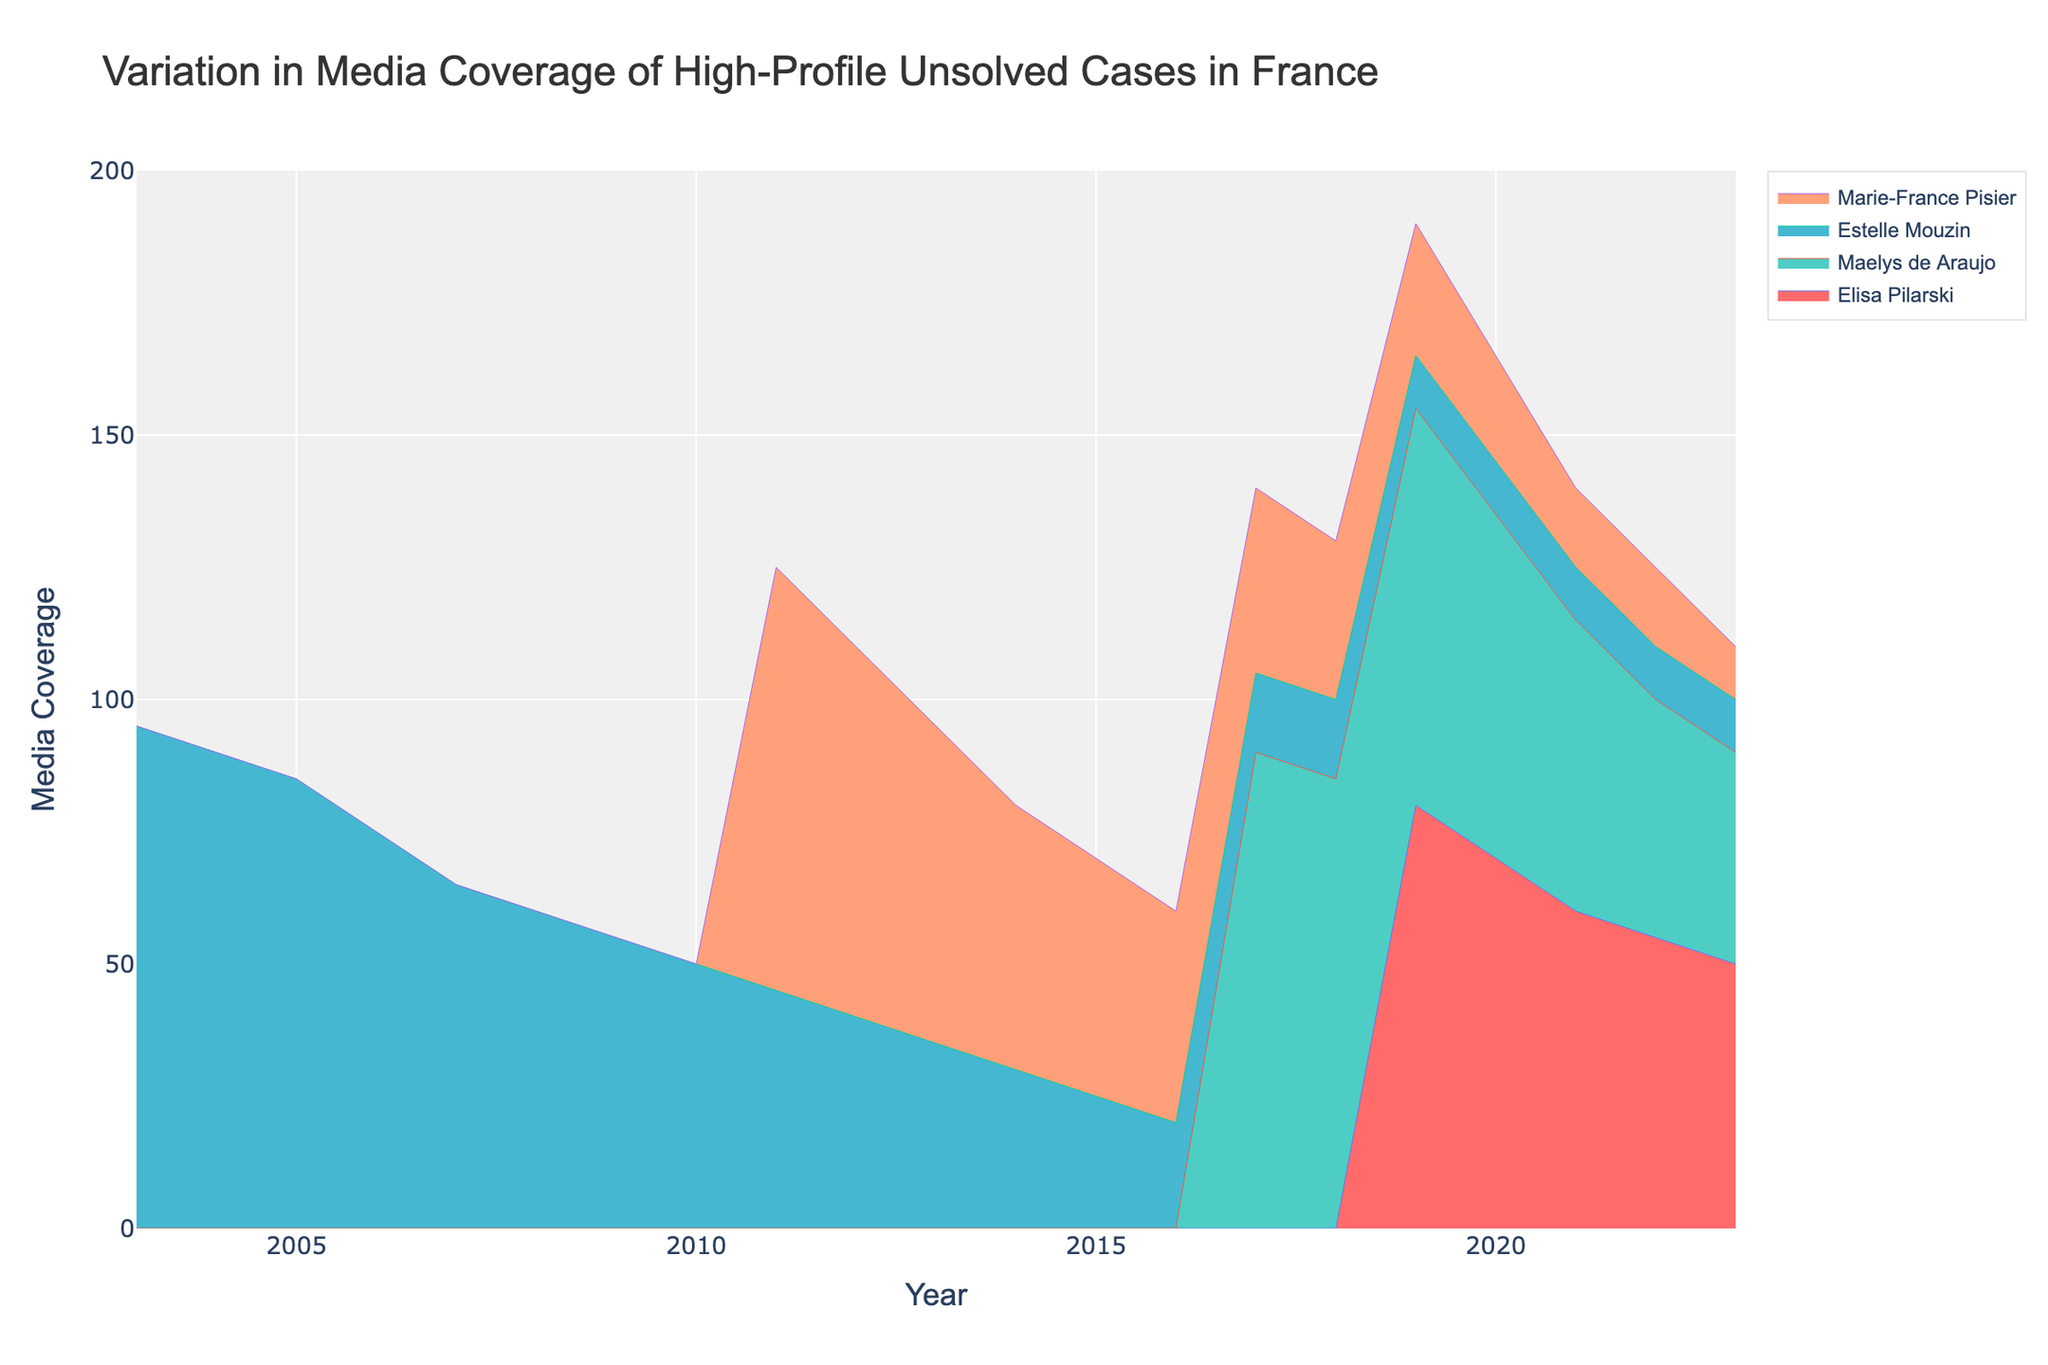What is the title of the figure? The title is usually written at the top of a plot, helping to give context to the data represented. Here it reads 'Variation in Media Coverage of High-Profile Unsolved Cases in France'.
Answer: Variation in Media Coverage of High-Profile Unsolved Cases in France What are the axes labels in the figure? Axes labels provide information about what each axis represents. Here, the x-axis is labeled 'Year' and the y-axis is labeled 'Media Coverage'.
Answer: 'Year' and 'Media Coverage' Which case had the highest media coverage in the initial year provided for that case? By looking at each initial year for all cases, we see that Estelle Mouzin in 2003 has the highest initial media coverage with a value of 95.
Answer: Estelle Mouzin in 2003 Between 2017 and 2018, did public awareness for Marie-France Pisier increase, decrease, or stay the same? We look at the 'Public Awareness' values for Marie-France Pisier for the years 2017 and 2018. It decreases from 30 to 25.
Answer: Decrease Which case had the most consistent level of media coverage from its initial year to 2023? Consistency is indicated by the least amount of variation over the years. Inspecting the plot, Estelle Mouzin has a consistently descending media coverage value, but the trend is slow and steady, showing more consistency compared to others.
Answer: Estelle Mouzin In what year did Maelys de Araujo’s media coverage drop below 50? We trace the line for Maelys de Araujo in the figure and find that it first falls below 50 in the year 2021.
Answer: 2021 How does the media coverage in 2023 for Elisa Pilarski compare to that of Estelle Mouzin? By comparing the media coverage values for 2023, we see Elisa Pilarski is at 50 while Estelle Mouzin is at 10, meaning Elisa Pilarski's media coverage is higher.
Answer: Elisa Pilarski's media coverage is higher What was the average public awareness for Maelys de Araujo from 2017 to 2023? We sum the 'Public Awareness' values for Maelys de Araujo from 2017 to 2023 (85+80+70+60+50+40+35=420) and then divide by the number of years (7).
Answer: 60 Which case showed a decrease in media coverage every year? By inspecting the trend lines, Elisa Pilarski and Maelys de Araujo both show a yearly decline, but Elisa Pilarski has a more gradual and continuous yearly drop.
Answer: Elisa Pilarski Which year had the highest combined media coverage for all cases? We sum the media coverage for each year across all cases and find the year with the highest total. The peak is clearly visible, and calculations would confirm 2017 having the highest combined coverage.
Answer: 2017 